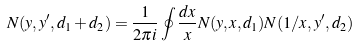<formula> <loc_0><loc_0><loc_500><loc_500>N ( y , y ^ { \prime } , d _ { 1 } + d _ { 2 } ) = { \frac { 1 } { 2 \pi i } } \oint { \frac { d x } { x } } N ( y , x , d _ { 1 } ) N ( 1 / x , y ^ { \prime } , d _ { 2 } )</formula> 